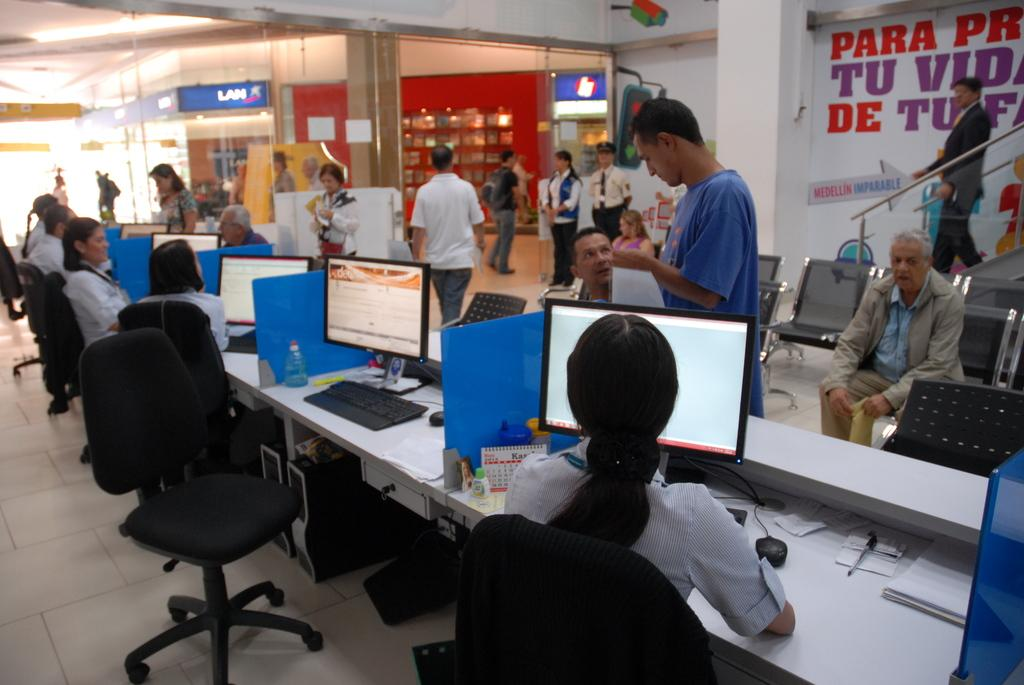What are the people in the image doing? Some people are walking, and some are sitting in the image. Can you describe the people who are sitting? Some of the people sitting are in front of computers. What type of environment is depicted in the image? The setting appears to be an office. What type of border is visible around the computers in the image? There is no mention of a border around the computers in the image. Can you tell me how many ducks are present in the image? There are no ducks visible in the image. 